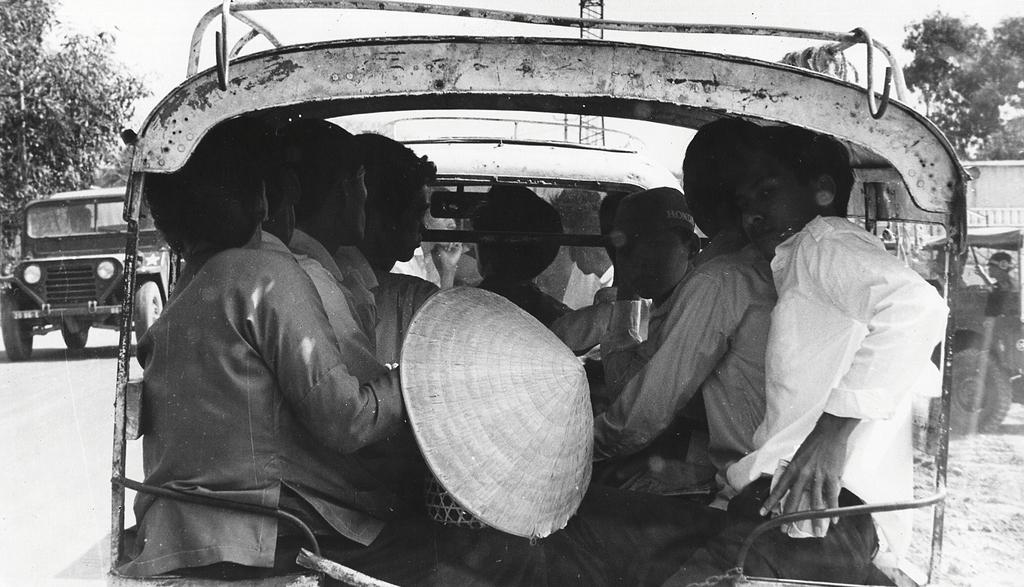What is the color scheme of the image? The image is black and white. What can be seen on the road in the image? There are vehicles on the road in the image. Are there any people visible in the vehicles? Yes, there are people inside a vehicle in the image. What type of natural scenery is visible in the background of the image? There are trees in the background of the image. What else can be seen in the background of the image? The sky is visible in the background of the image. How many spiders are crawling on the vehicles in the image? There are no spiders visible in the image; it features vehicles on a road with people inside. What type of architectural structure can be seen in the background of the image? There is no specific architectural structure mentioned in the facts, only trees and the sky are visible in the background. 